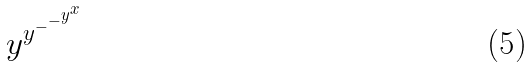<formula> <loc_0><loc_0><loc_500><loc_500>y ^ { y ^ { - ^ { - ^ { y ^ { x } } } } }</formula> 